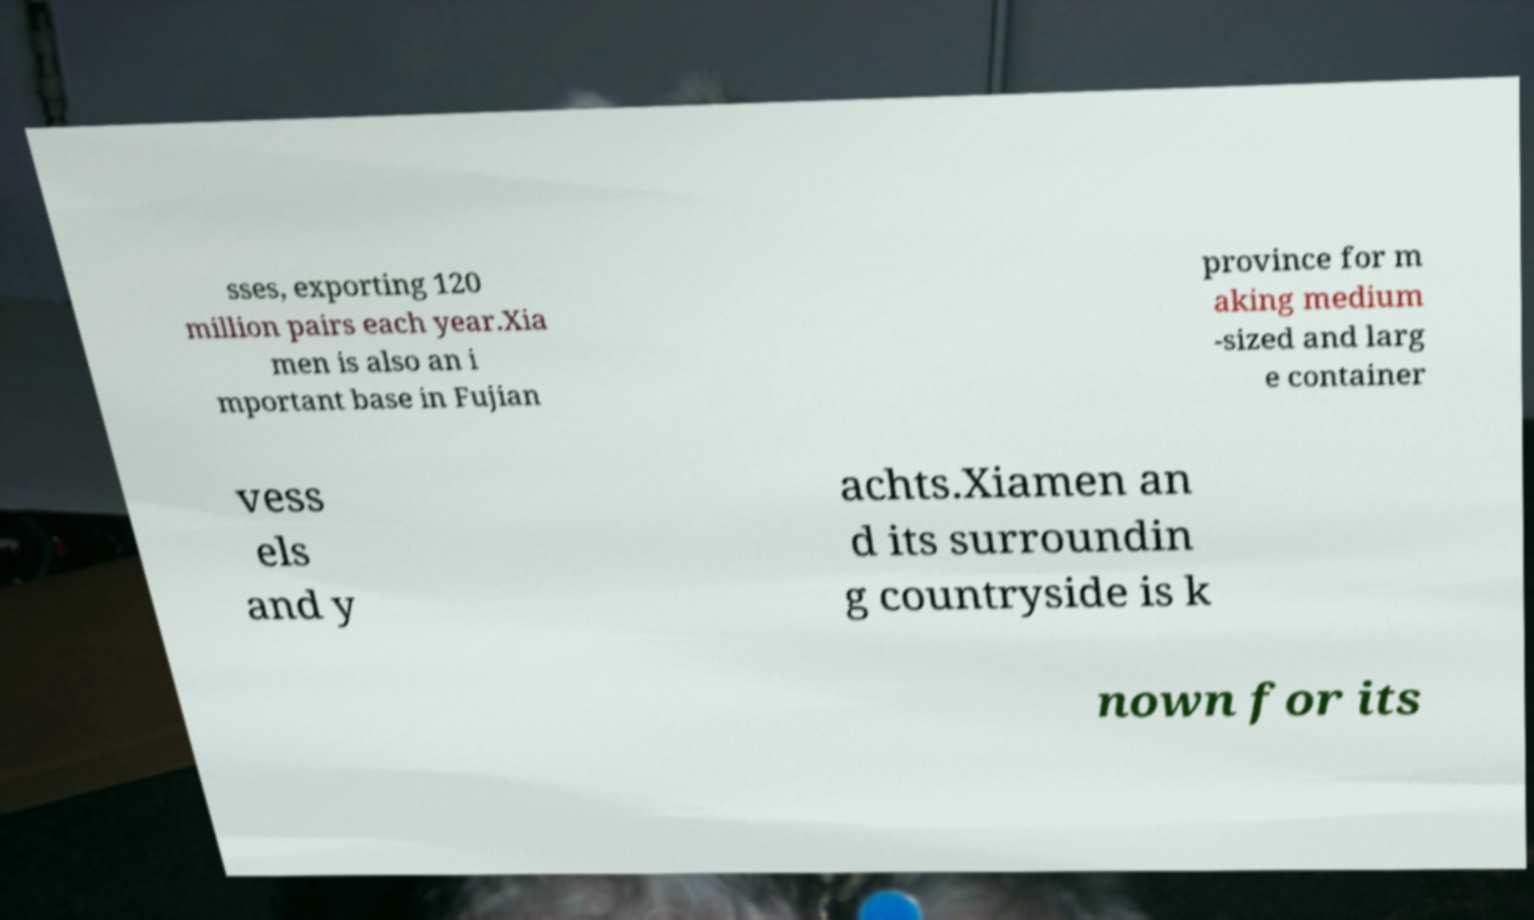What messages or text are displayed in this image? I need them in a readable, typed format. sses, exporting 120 million pairs each year.Xia men is also an i mportant base in Fujian province for m aking medium -sized and larg e container vess els and y achts.Xiamen an d its surroundin g countryside is k nown for its 